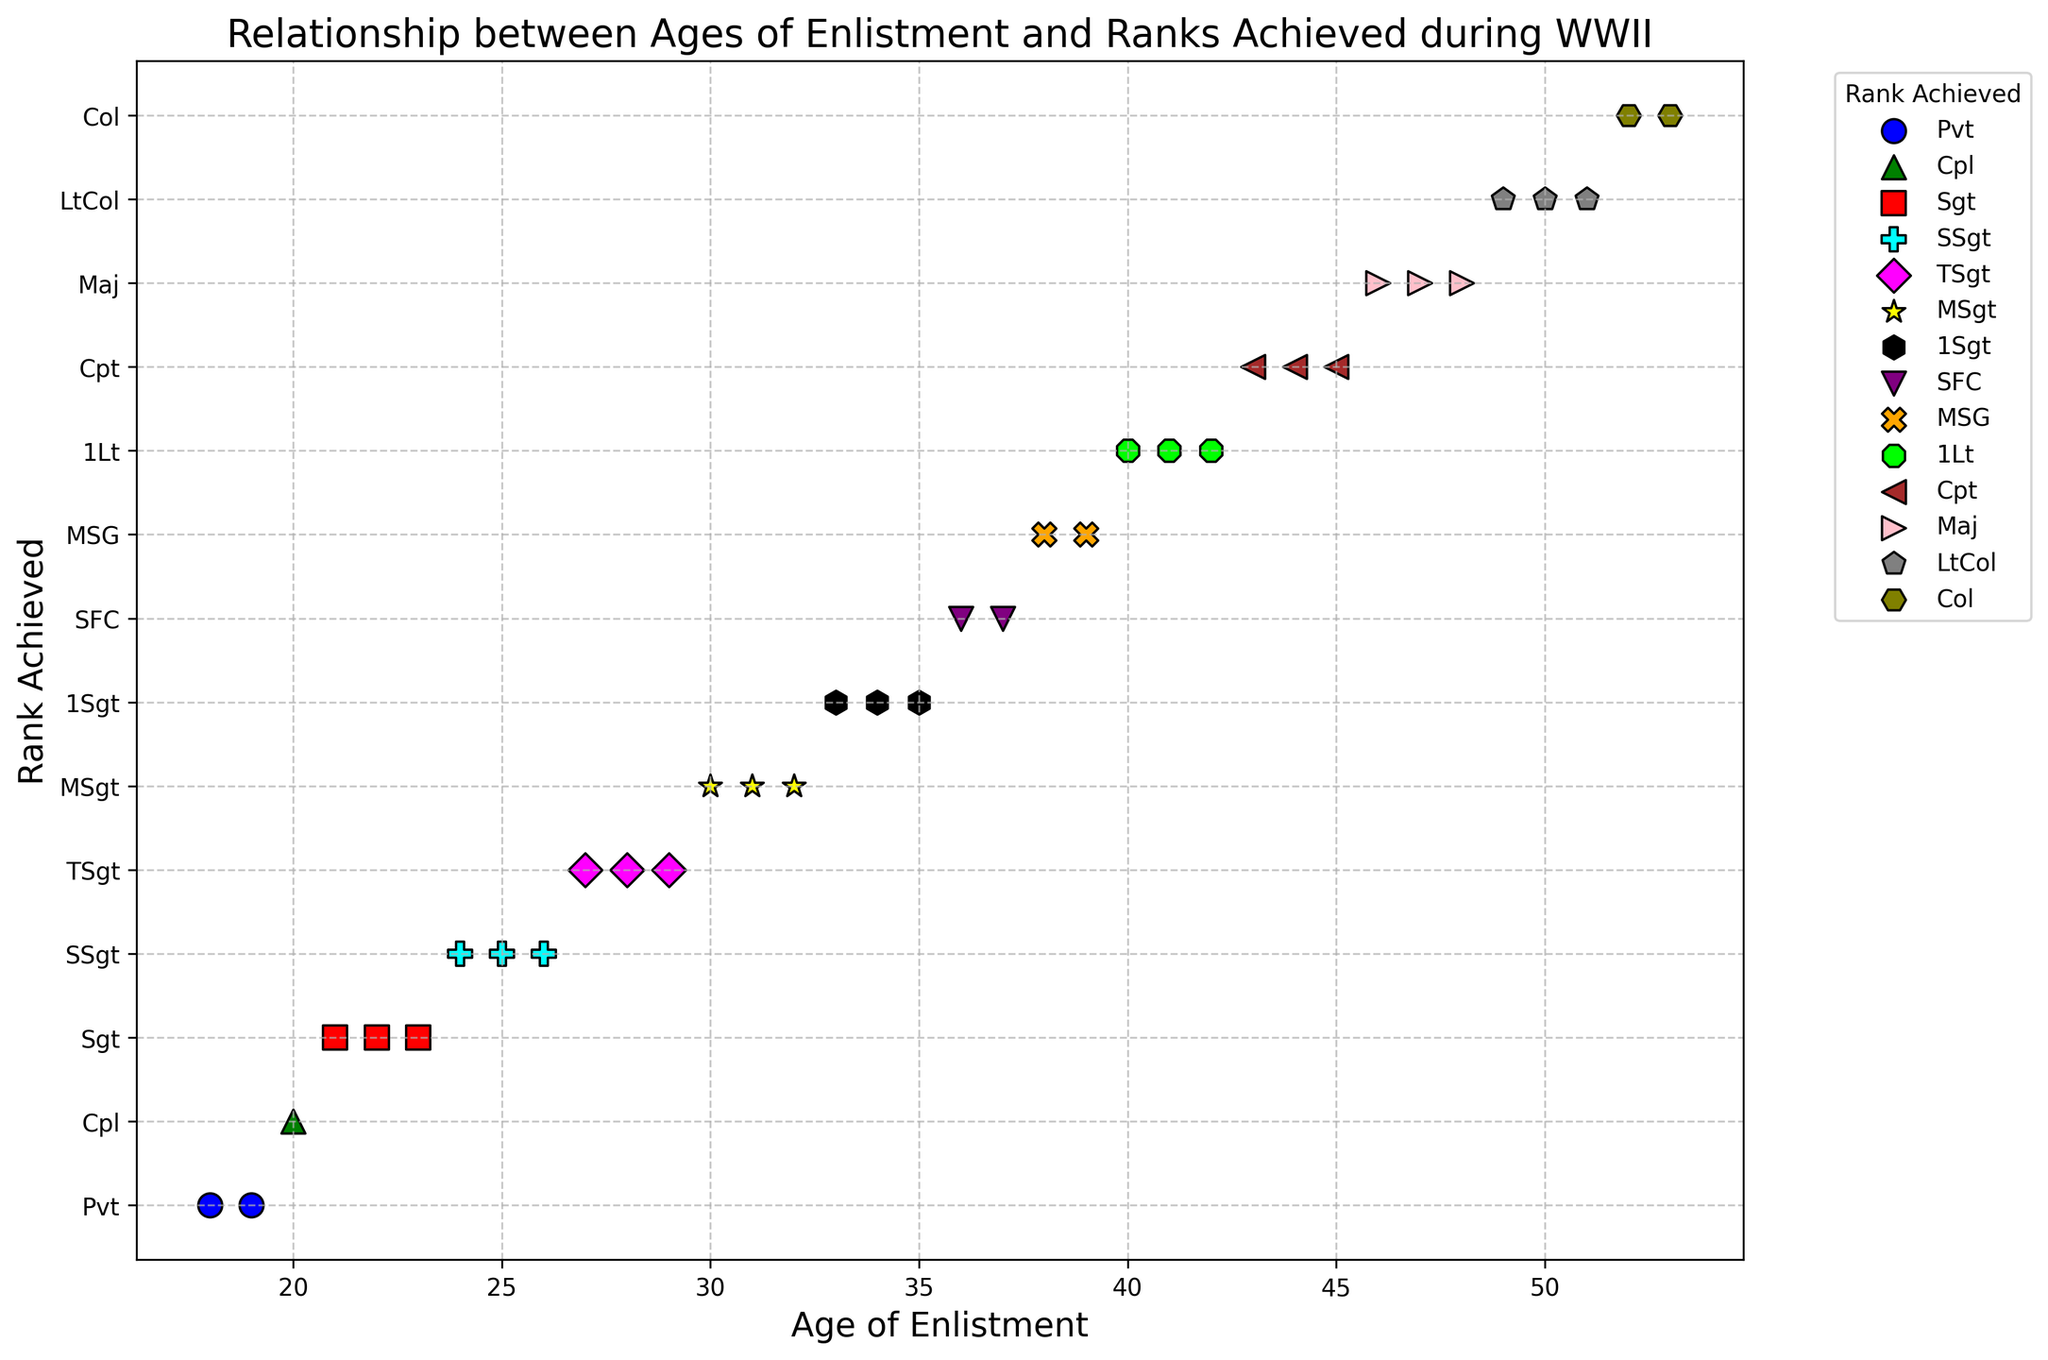Which rank is most commonly achieved by those who enlisted at the age of 30? The scatter plot shows that those who enlisted at the age of 30 achieved the 'MSgt' rank.
Answer: MSgt Which enlisted age appears most frequently for achieving the 'Sgt' rank? In the scatter plot, the 'Sgt' rank corresponds to enlisted ages of 21, 22, and 23. Each age appears once, so no single age is most frequent.
Answer: 21, 22, 23 Compare the rank achieved by a 20-year-old enlistee with that achieved by a 29-year-old enlistee. The scatter plot shows that a 20-year-old achieved the rank of 'Cpl', while a 29-year-old achieved the rank of 'TSgt'. The rank 'TSgt' is higher than 'Cpl'.
Answer: 29-year-old higher rank Which rank is indicated by the 'black' color marker? The 'black' color marker is associated with the '1Sgt' rank as per the scatter plot.
Answer: 1Sgt Identify the highest rank achieved by enlistees and specify the corresponding age(s). The highest rank is 'Col', achieved by enlistees at ages 52 and 53.
Answer: Col, 52 and 53 What's the average age of enlistees who achieved the rank 'Cpt'? The ages for the rank 'Cpt' are 43, 44, and 45. Sum these ages (43 + 44 + 45 = 132) and divide by 3. The average age is 132 / 3 = 44.
Answer: 44 Which marker shape is used for the 'TSgt' rank, and at which ages is it achieved? The marker shape for the 'TSgt' rank is a diamond ('D'). It is achieved at ages 27, 28, and 29.
Answer: Diamond, 27, 28, 29 